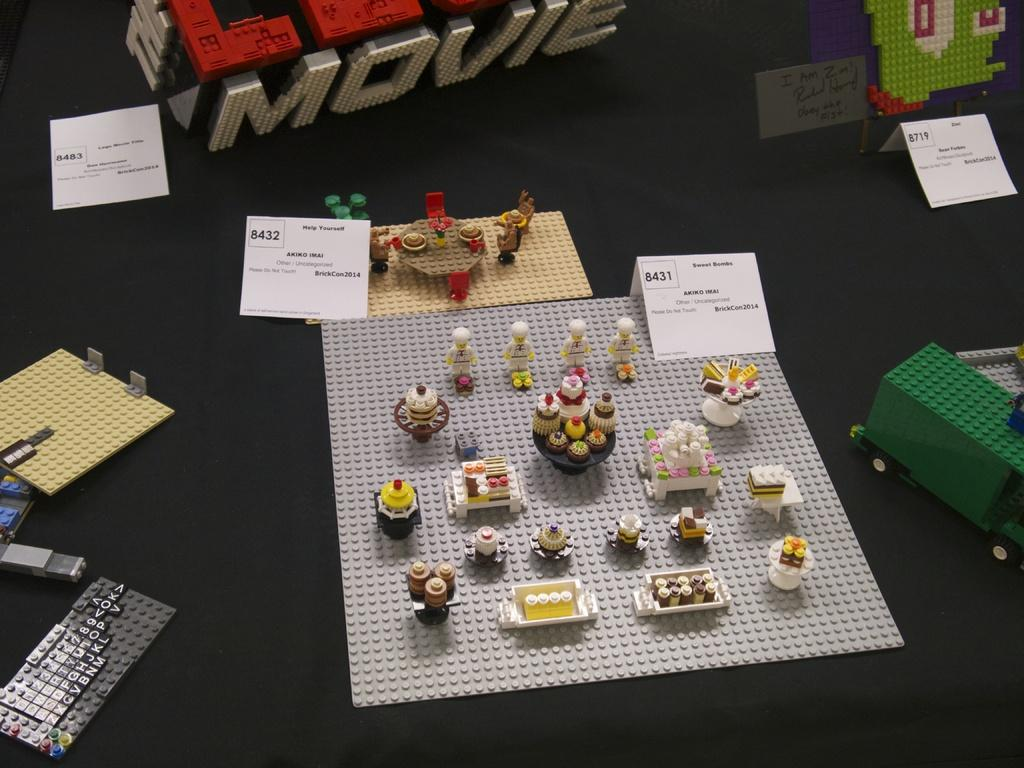What type of structures can be seen in the image? There are lego structures in the image. What type of food is present in the image? There are cupcakes in the image. What color are the boards in the image? The boards in the image are white. What color is the surface on which objects are placed in the image? The surface is black. What is the chance of an earthquake happening in the image? There is no indication of an earthquake or any natural disaster in the image. How can the white color boards be used to measure distances in the image? The white color boards are not used for measuring distances in the image; they are simply a part of the background. 